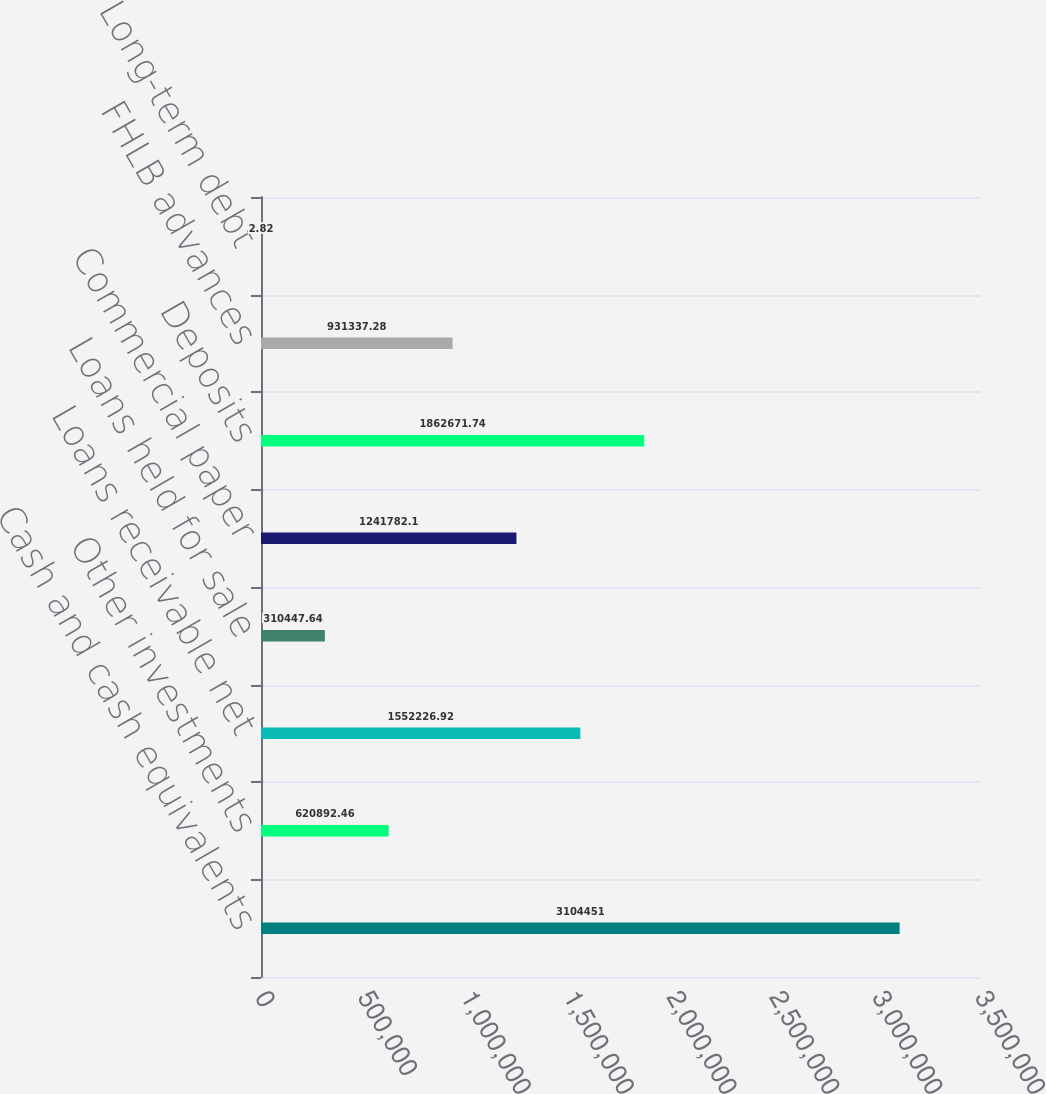Convert chart to OTSL. <chart><loc_0><loc_0><loc_500><loc_500><bar_chart><fcel>Cash and cash equivalents<fcel>Other investments<fcel>Loans receivable net<fcel>Loans held for sale<fcel>Commercial paper<fcel>Deposits<fcel>FHLB advances<fcel>Long-term debt<nl><fcel>3.10445e+06<fcel>620892<fcel>1.55223e+06<fcel>310448<fcel>1.24178e+06<fcel>1.86267e+06<fcel>931337<fcel>2.82<nl></chart> 